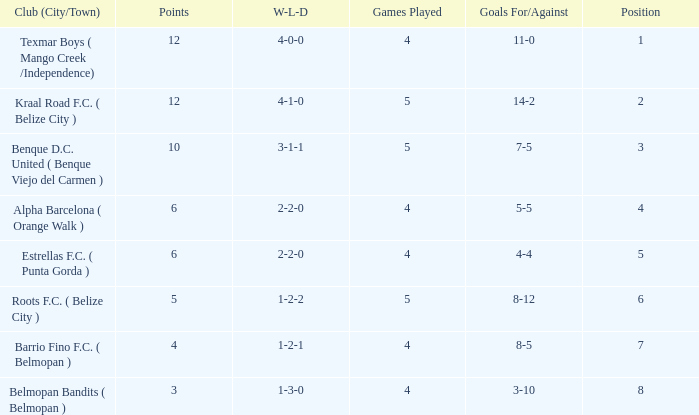What is the minimum games played with goals for/against being 7-5 5.0. 